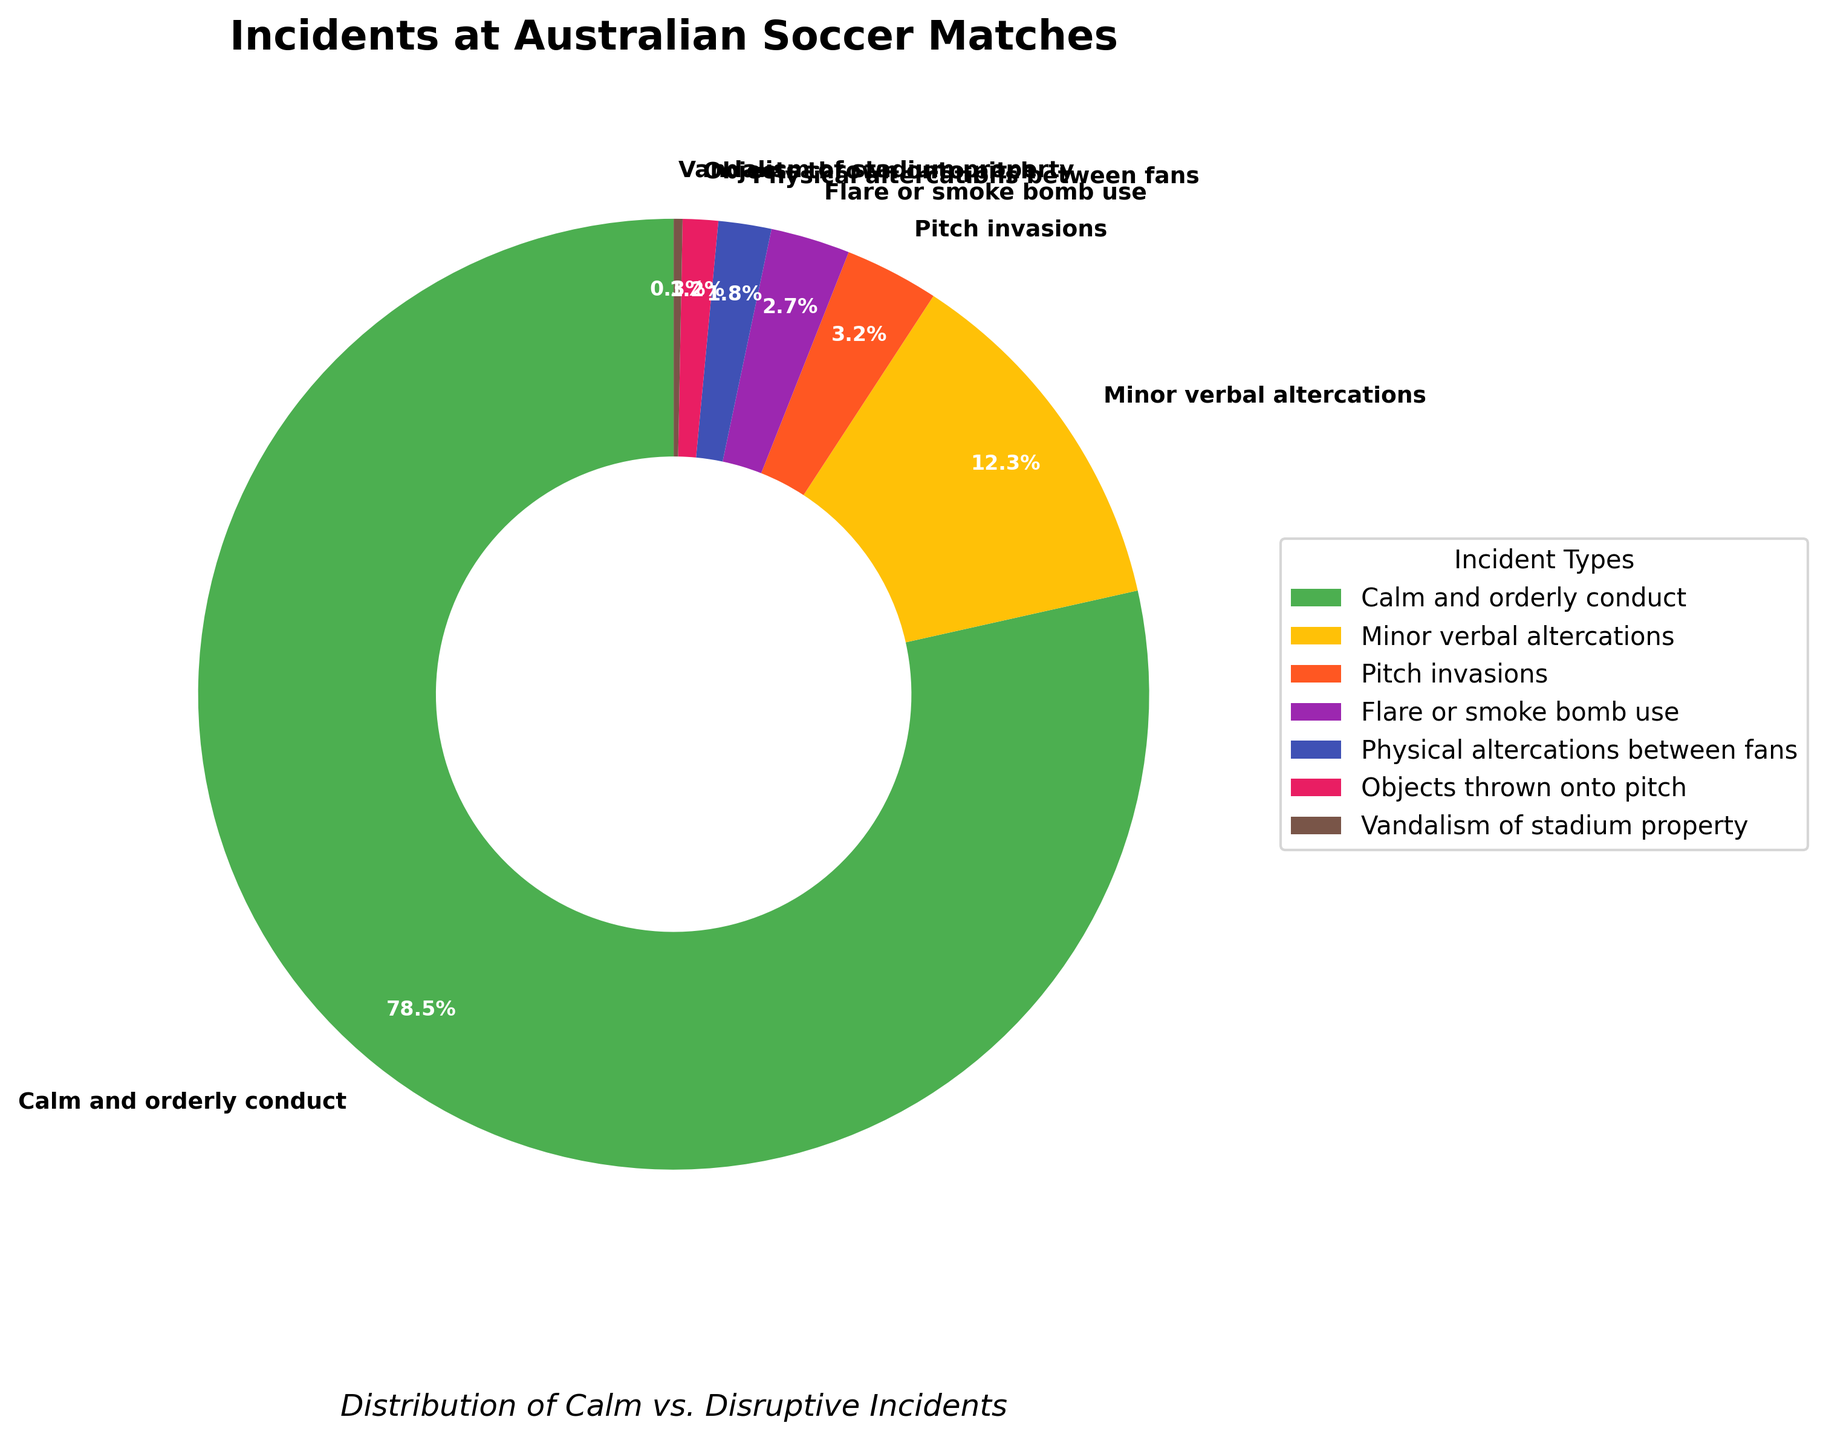What percentage of incidents categorized as calm and orderly conduct? By observing the pie chart, look for the segment labeled "Calm and orderly conduct" and note its percentage value.
Answer: 78.5% Which incident type has the lowest percentage? In the pie chart, identify the segment with the smallest size and check its label. The smallest segment is "Vandalism of stadium property".
Answer: Vandalism of stadium property What is the combined percentage of pitch invasions and flare or smoke bomb use? Find the percentage values of "Pitch invasions" and "Flare or smoke bomb use" from the pie chart. Sum these values (3.2% + 2.7%).
Answer: 5.9% How much more common are calm and orderly incidents compared to minor verbal altercations? Identify the percentage for both "Calm and orderly conduct" and "Minor verbal altercations". Subtract the latter from the former (78.5% - 12.3%).
Answer: 66.2% What is the second most frequent incident type? Examine the pie chart and identify the second largest segment. The second largest segment represents "Minor verbal altercations".
Answer: Minor verbal altercations How does the percentage of physical altercations between fans compare to objects thrown onto the pitch? Refer to the pie chart to find the percentages of "Physical altercations between fans" and "Objects thrown onto pitch" and compare them. "Physical altercations between fans" has 1.8%, and "Objects thrown onto pitch" has 1.2%.
Answer: Physical altercations between fans is higher Is the percentage of flare or smoke bomb use greater than or less than 3%? Locate the "Flare or smoke bomb use" label in the pie chart and check if its percentage is above or below 3%. It shows 2.7%.
Answer: Less than 3% Which incident types together make up less than 5% of the total? Look for incident types in the pie chart with individual percentages and sum them up until the total is less than 5%: "Vandalism of stadium property" (0.3%), "Objects thrown onto pitch" (1.2%), "Physical altercations between fans" (1.8%), and "Flare or smoke bomb use" (2.7%). Only "Vandalism of stadium property" and "Objects thrown onto pitch" and "Physical altercations between fans" alone are less than (0.3% + 1.2% + 1.8%) = 3.3%.
Answer: Three lowest incident types combined What percentage of total incidents are considered serious (physical altercations, pitch invasions, flare/smoke bomb use)? Add the percentages of "Pitch invasions", "Flare or smoke bomb use" and "Physical altercations between fans". (3.2% + 2.7% + 1.8%).
Answer: 7.7% 